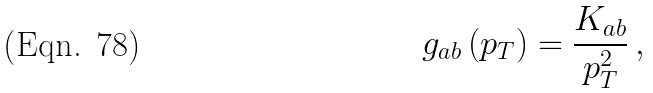<formula> <loc_0><loc_0><loc_500><loc_500>g _ { a b } \left ( p _ { T } \right ) = \frac { K _ { a b } } { p _ { T } ^ { 2 } } \, ,</formula> 